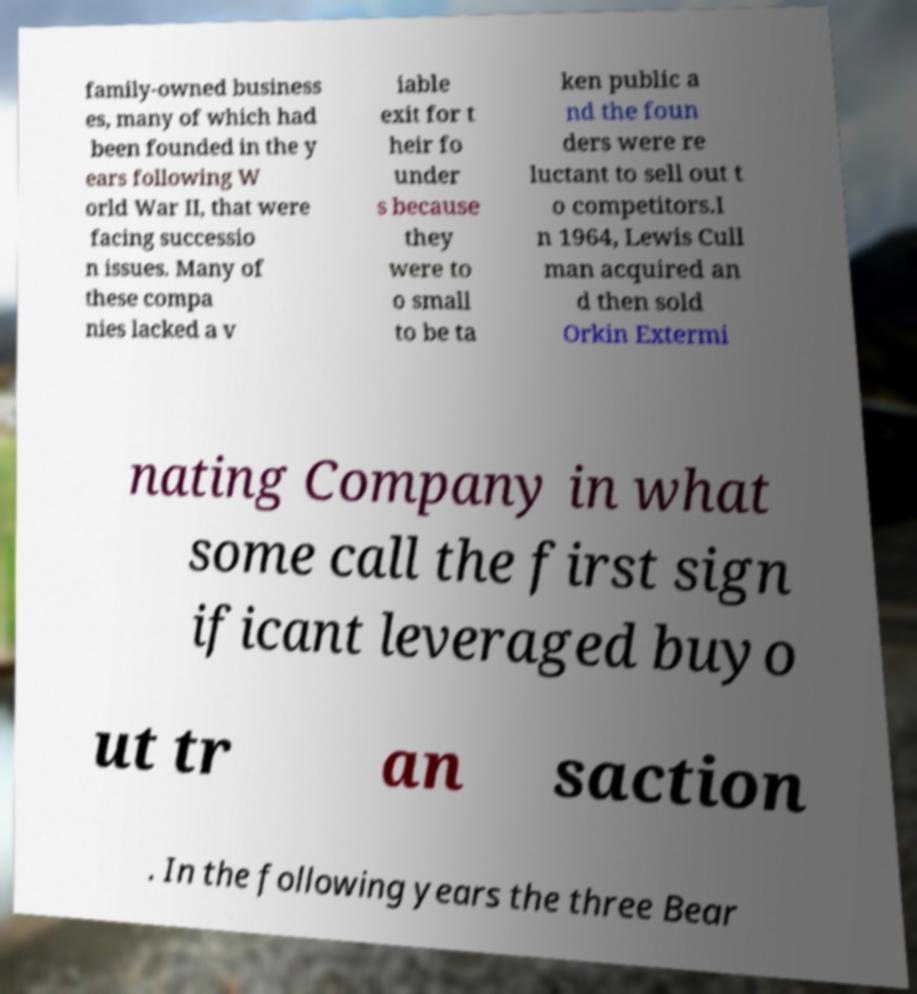Please identify and transcribe the text found in this image. family-owned business es, many of which had been founded in the y ears following W orld War II, that were facing successio n issues. Many of these compa nies lacked a v iable exit for t heir fo under s because they were to o small to be ta ken public a nd the foun ders were re luctant to sell out t o competitors.I n 1964, Lewis Cull man acquired an d then sold Orkin Extermi nating Company in what some call the first sign ificant leveraged buyo ut tr an saction . In the following years the three Bear 